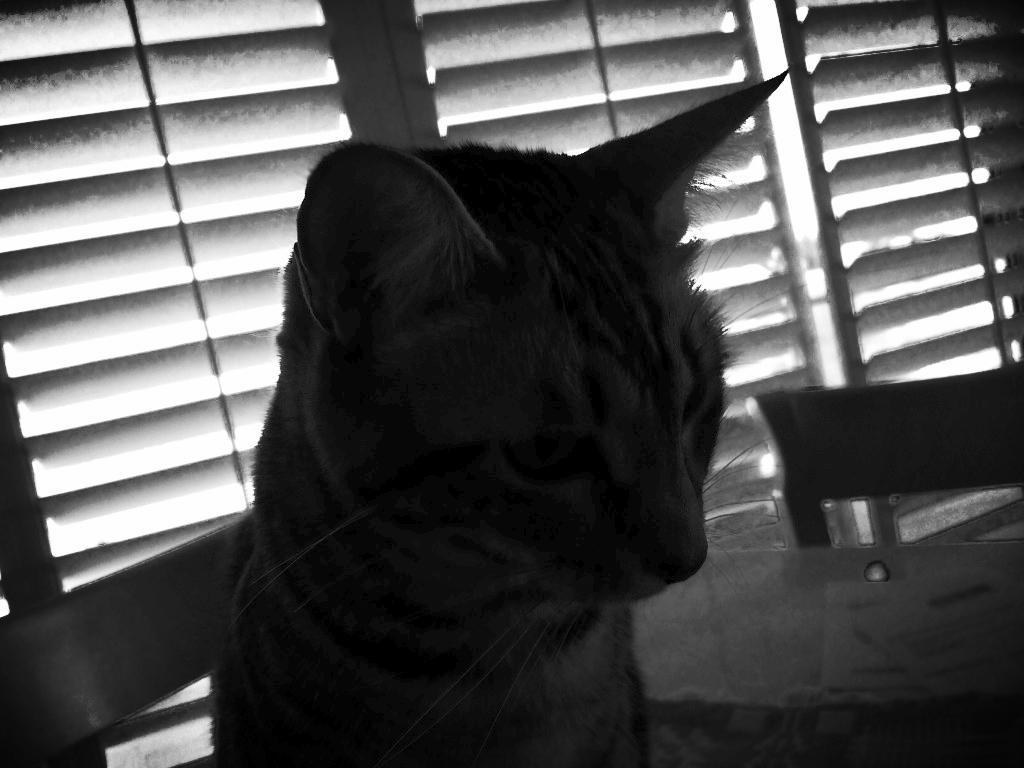Please provide a concise description of this image. In this image I can see a cat, behind this there is the window. 